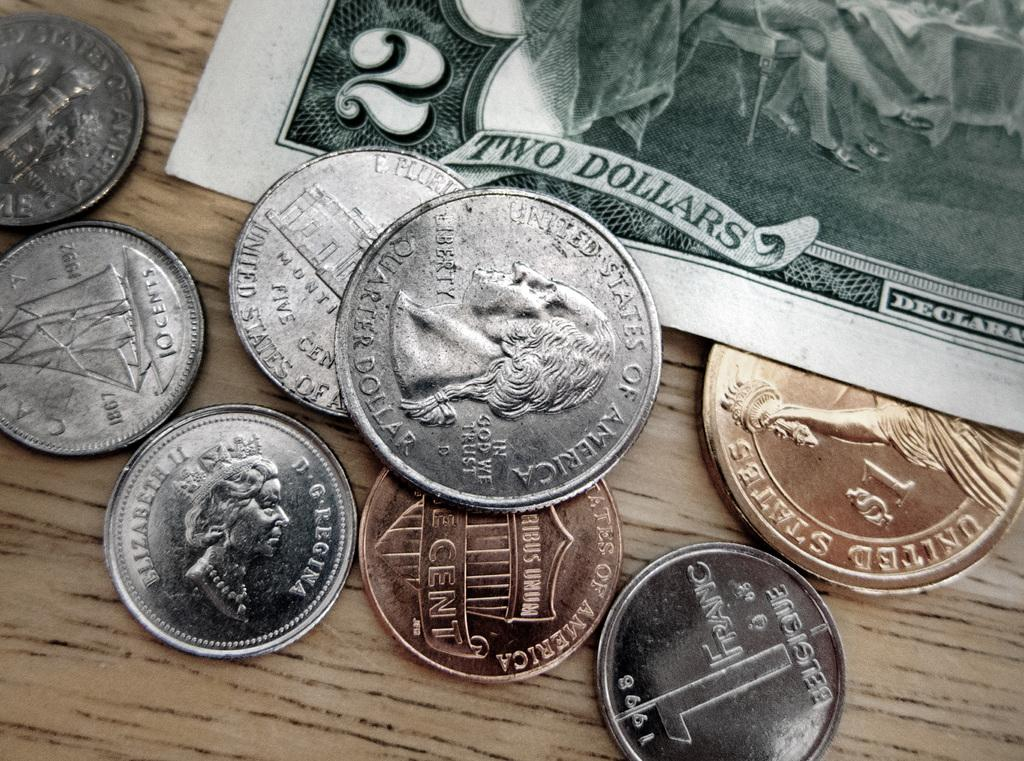<image>
Present a compact description of the photo's key features. Some change and a two dollar bill are on a surface. 